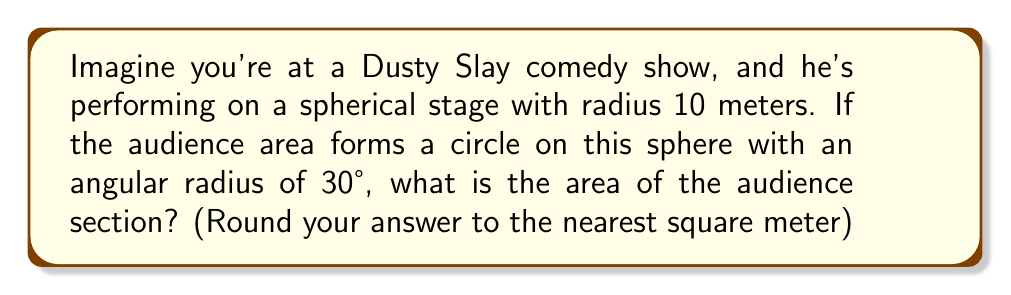Can you solve this math problem? Let's approach this step-by-step:

1) On a sphere, the area of a circle (called a spherical cap) is different from a flat circle. The formula for the area of a spherical cap is:

   $$A = 2\pi R^2(1-\cos\theta)$$

   Where $R$ is the radius of the sphere and $\theta$ is the angular radius in radians.

2) We're given $R = 10$ meters and $\theta = 30°$. We need to convert 30° to radians:

   $$30° \times \frac{\pi}{180°} = \frac{\pi}{6} \approx 0.5236 \text{ radians}$$

3) Now we can plug these values into our formula:

   $$A = 2\pi (10)^2(1-\cos(\frac{\pi}{6}))$$

4) Let's calculate this step-by-step:
   
   $$\cos(\frac{\pi}{6}) \approx 0.8660$$
   
   $$1 - 0.8660 = 0.1340$$
   
   $$2\pi (10)^2 = 200\pi$$
   
   $$200\pi \times 0.1340 \approx 84.2256$$

5) Rounding to the nearest square meter:

   $$84.2256 \approx 84 \text{ m}^2$$
Answer: $84 \text{ m}^2$ 